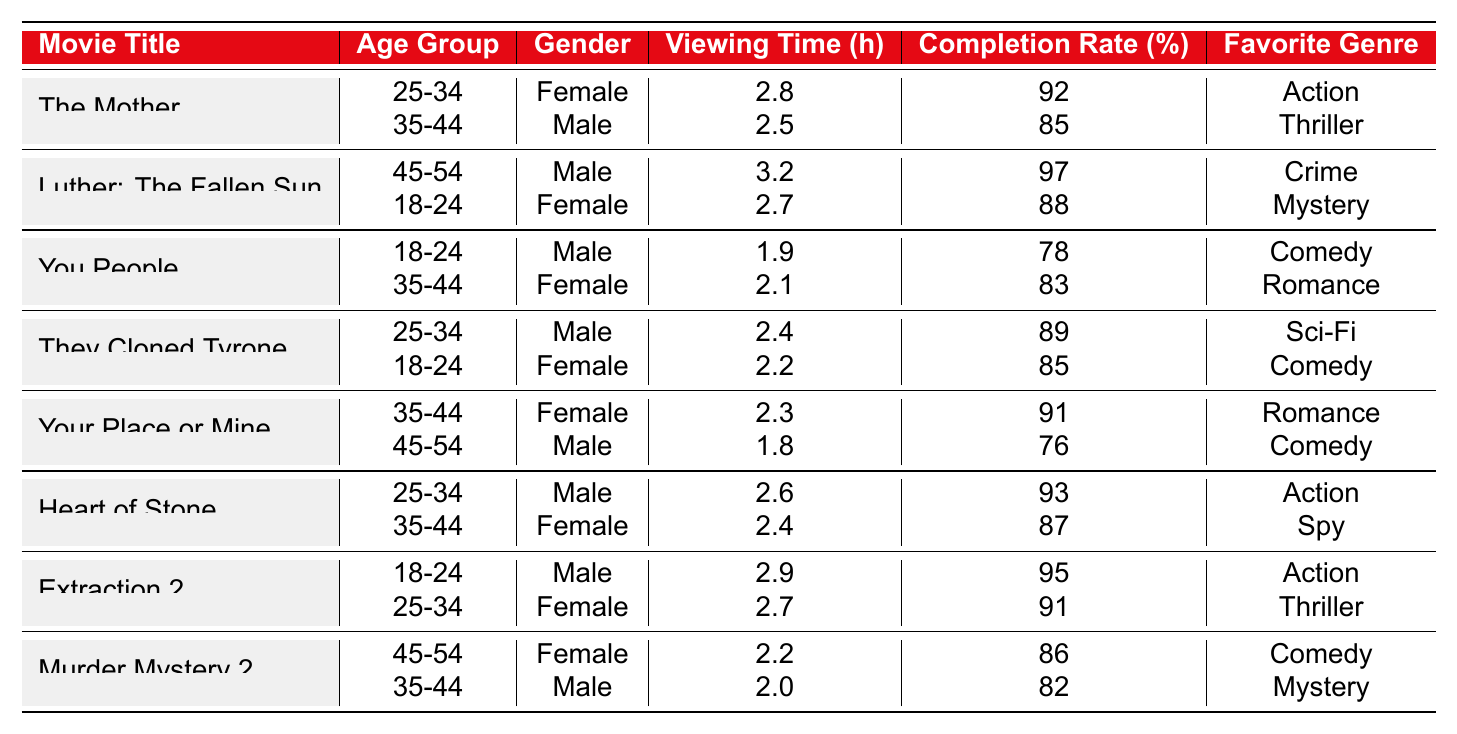What is the viewing time for "The Mother" among the 25-34 age group? The table shows that the viewing time for "The Mother" in the 25-34 age group is 2.8 hours.
Answer: 2.8 hours What is the completion rate of "Luther: The Fallen Sun" for the 18-24 age group? According to the table, the completion rate for "Luther: The Fallen Sun" in the 18-24 age group is 88%.
Answer: 88% Which movie has the highest completion rate, and what is that rate? The highest completion rate in the table is for "Luther: The Fallen Sun" at 97%.
Answer: 97% What is the average viewing time for movies in the "Action" genre? The viewing times for "The Mother" (2.8), "Heart of Stone" (2.6), and "Extraction 2" (2.9) total 8.3 hours. Dividing by 3 gives an average of approximately 2.77 hours.
Answer: 2.77 hours Is there a movie that both genders aged 25-34 watched in 2023? Yes, "The Mother" and "Heart of Stone" were both watched by 25-34 age group males and females, confirming the presence of a movie watched by both genders in this age group.
Answer: Yes What gender had a completion rate above 90% in the "Thriller" genre? The female demographic for "Extraction 2" has a completion rate of 91%, which is above 90% in the "Thriller" genre.
Answer: Female Did the 35-44 age group show higher completion rates for comedies or romances? For the 35-44 age group, completion rates were 82% for "You People" (Romance) and 76% for "Your Place or Mine" (Comedy). Since 82% is higher, it's evident Romance had a better completion rate.
Answer: Romance Which two movies had the most similar viewing times for the 25-34 age group? "Heart of Stone" (2.6) and "They Cloned Tyrone" (2.4) had the closest viewing times in the 25-34 age group, differing by only 0.2 hours.
Answer: "Heart of Stone" and "They Cloned Tyrone" What is the favorite genre of the male 45-54 age group watching "Murder Mystery 2"? The favorite genre for the male 45-54 age group in "Murder Mystery 2" is Mystery, as indicated in the table.
Answer: Mystery Which movie had a viewing time greater than 3 hours? "Luther: The Fallen Sun" is the only movie with a viewing time greater than 3 hours, specifically 3.2 hours.
Answer: "Luther: The Fallen Sun" 